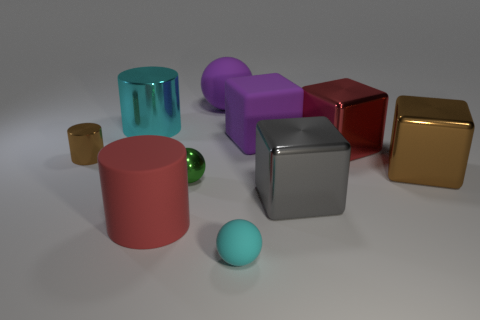Subtract all small brown metallic cylinders. How many cylinders are left? 2 Subtract all gray blocks. How many blocks are left? 3 Subtract all spheres. How many objects are left? 7 Subtract all cyan cubes. Subtract all brown cylinders. How many cubes are left? 4 Subtract all big cyan metallic objects. Subtract all big rubber balls. How many objects are left? 8 Add 1 large balls. How many large balls are left? 2 Add 4 tiny purple metal cubes. How many tiny purple metal cubes exist? 4 Subtract 0 blue cylinders. How many objects are left? 10 